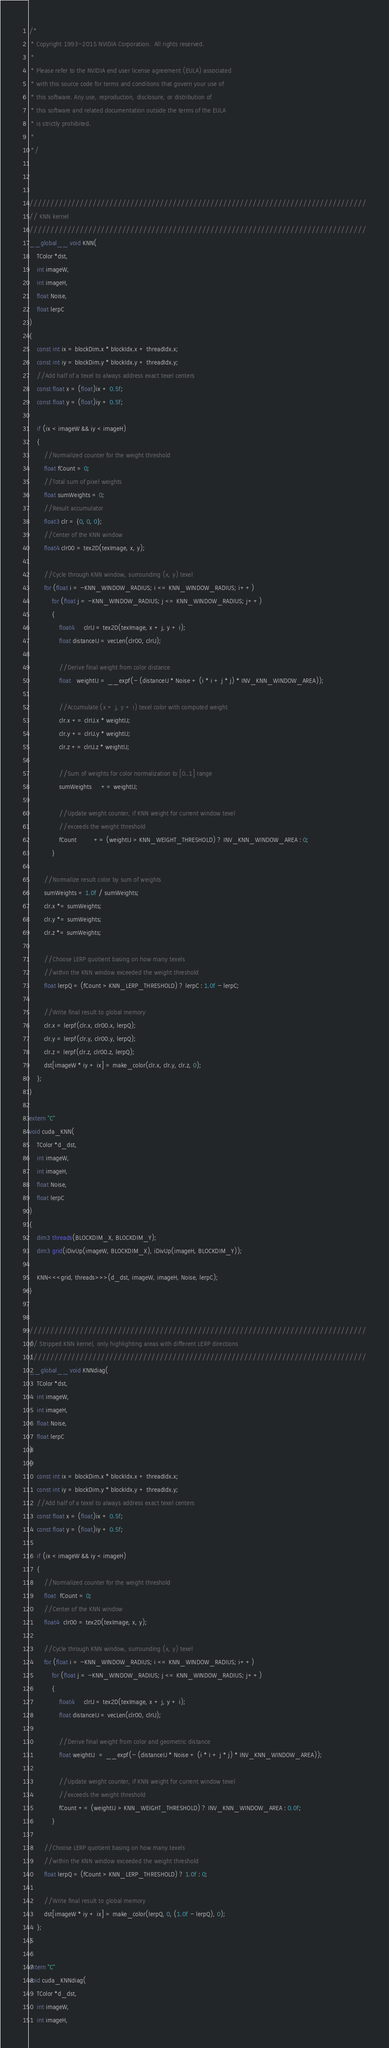Convert code to text. <code><loc_0><loc_0><loc_500><loc_500><_Cuda_>/*
 * Copyright 1993-2015 NVIDIA Corporation.  All rights reserved.
 *
 * Please refer to the NVIDIA end user license agreement (EULA) associated
 * with this source code for terms and conditions that govern your use of
 * this software. Any use, reproduction, disclosure, or distribution of
 * this software and related documentation outside the terms of the EULA
 * is strictly prohibited.
 *
 */



////////////////////////////////////////////////////////////////////////////////
// KNN kernel
////////////////////////////////////////////////////////////////////////////////
__global__ void KNN(
    TColor *dst,
    int imageW,
    int imageH,
    float Noise,
    float lerpC
)
{
    const int ix = blockDim.x * blockIdx.x + threadIdx.x;
    const int iy = blockDim.y * blockIdx.y + threadIdx.y;
    //Add half of a texel to always address exact texel centers
    const float x = (float)ix + 0.5f;
    const float y = (float)iy + 0.5f;

    if (ix < imageW && iy < imageH)
    {
        //Normalized counter for the weight threshold
        float fCount = 0;
        //Total sum of pixel weights
        float sumWeights = 0;
        //Result accumulator
        float3 clr = {0, 0, 0};
        //Center of the KNN window
        float4 clr00 = tex2D(texImage, x, y);

        //Cycle through KNN window, surrounding (x, y) texel
        for (float i = -KNN_WINDOW_RADIUS; i <= KNN_WINDOW_RADIUS; i++)
            for (float j = -KNN_WINDOW_RADIUS; j <= KNN_WINDOW_RADIUS; j++)
            {
                float4     clrIJ = tex2D(texImage, x + j, y + i);
                float distanceIJ = vecLen(clr00, clrIJ);

                //Derive final weight from color distance
                float   weightIJ = __expf(- (distanceIJ * Noise + (i * i + j * j) * INV_KNN_WINDOW_AREA));

                //Accumulate (x + j, y + i) texel color with computed weight
                clr.x += clrIJ.x * weightIJ;
                clr.y += clrIJ.y * weightIJ;
                clr.z += clrIJ.z * weightIJ;

                //Sum of weights for color normalization to [0..1] range
                sumWeights     += weightIJ;

                //Update weight counter, if KNN weight for current window texel
                //exceeds the weight threshold
                fCount         += (weightIJ > KNN_WEIGHT_THRESHOLD) ? INV_KNN_WINDOW_AREA : 0;
            }

        //Normalize result color by sum of weights
        sumWeights = 1.0f / sumWeights;
        clr.x *= sumWeights;
        clr.y *= sumWeights;
        clr.z *= sumWeights;

        //Choose LERP quotient basing on how many texels
        //within the KNN window exceeded the weight threshold
        float lerpQ = (fCount > KNN_LERP_THRESHOLD) ? lerpC : 1.0f - lerpC;

        //Write final result to global memory
        clr.x = lerpf(clr.x, clr00.x, lerpQ);
        clr.y = lerpf(clr.y, clr00.y, lerpQ);
        clr.z = lerpf(clr.z, clr00.z, lerpQ);
        dst[imageW * iy + ix] = make_color(clr.x, clr.y, clr.z, 0);
    };
}

extern "C"
void cuda_KNN(
    TColor *d_dst,
    int imageW,
    int imageH,
    float Noise,
    float lerpC
)
{
    dim3 threads(BLOCKDIM_X, BLOCKDIM_Y);
    dim3 grid(iDivUp(imageW, BLOCKDIM_X), iDivUp(imageH, BLOCKDIM_Y));

    KNN<<<grid, threads>>>(d_dst, imageW, imageH, Noise, lerpC);
}


////////////////////////////////////////////////////////////////////////////////
// Stripped KNN kernel, only highlighting areas with different LERP directions
////////////////////////////////////////////////////////////////////////////////
__global__ void KNNdiag(
    TColor *dst,
    int imageW,
    int imageH,
    float Noise,
    float lerpC
)
{
    const int ix = blockDim.x * blockIdx.x + threadIdx.x;
    const int iy = blockDim.y * blockIdx.y + threadIdx.y;
    //Add half of a texel to always address exact texel centers
    const float x = (float)ix + 0.5f;
    const float y = (float)iy + 0.5f;

    if (ix < imageW && iy < imageH)
    {
        //Normalized counter for the weight threshold
        float  fCount = 0;
        //Center of the KNN window
        float4  clr00 = tex2D(texImage, x, y);

        //Cycle through KNN window, surrounding (x, y) texel
        for (float i = -KNN_WINDOW_RADIUS; i <= KNN_WINDOW_RADIUS; i++)
            for (float j = -KNN_WINDOW_RADIUS; j <= KNN_WINDOW_RADIUS; j++)
            {
                float4     clrIJ = tex2D(texImage, x + j, y + i);
                float distanceIJ = vecLen(clr00, clrIJ);

                //Derive final weight from color and geometric distance
                float weightIJ  = __expf(- (distanceIJ * Noise + (i * i + j * j) * INV_KNN_WINDOW_AREA));

                //Update weight counter, if KNN weight for current window texel
                //exceeds the weight threshold
                fCount += (weightIJ > KNN_WEIGHT_THRESHOLD) ? INV_KNN_WINDOW_AREA : 0.0f;
            }

        //Choose LERP quotient basing on how many texels
        //within the KNN window exceeded the weight threshold
        float lerpQ = (fCount > KNN_LERP_THRESHOLD) ? 1.0f : 0;

        //Write final result to global memory
        dst[imageW * iy + ix] = make_color(lerpQ, 0, (1.0f - lerpQ), 0);
    };
}

extern "C"
void cuda_KNNdiag(
    TColor *d_dst,
    int imageW,
    int imageH,</code> 